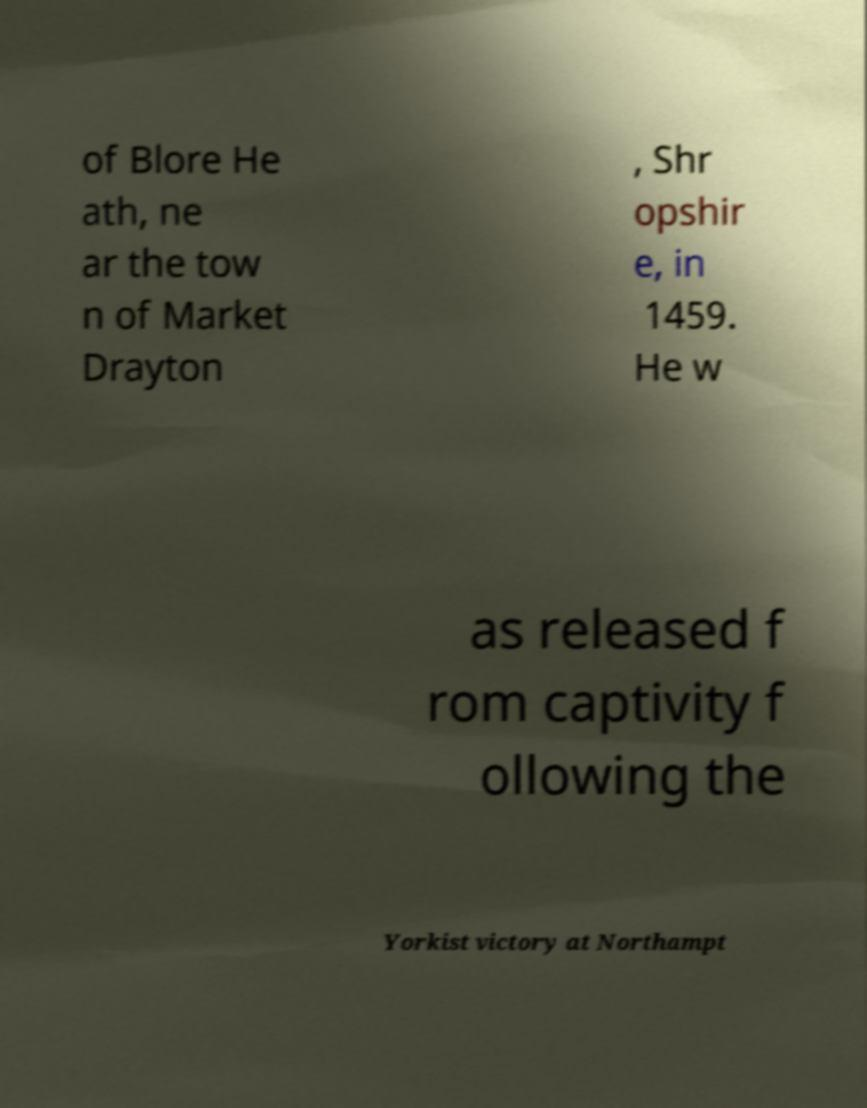I need the written content from this picture converted into text. Can you do that? of Blore He ath, ne ar the tow n of Market Drayton , Shr opshir e, in 1459. He w as released f rom captivity f ollowing the Yorkist victory at Northampt 